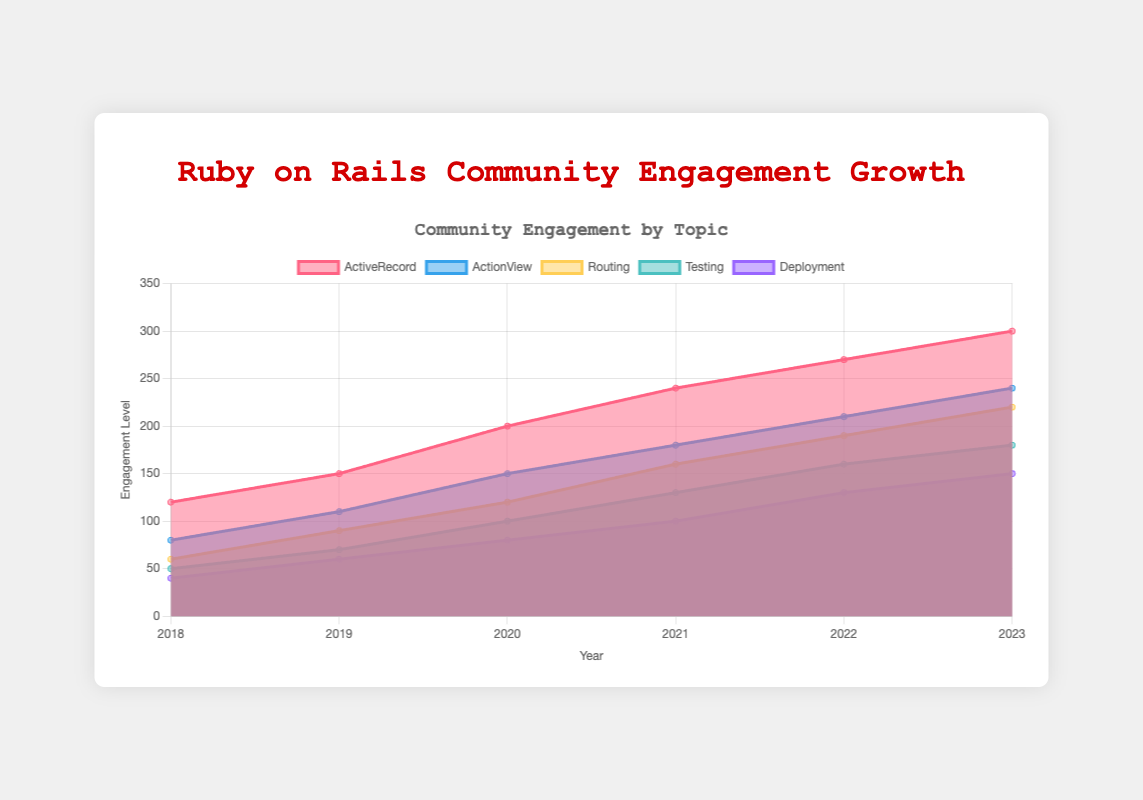What is the title of the chart? The title of the chart is displayed prominently at the top of the figure.
Answer: Ruby on Rails Community Engagement Growth How many topics are represented in the area chart? By observing the legend and the different colored areas, we can count five distinct topics.
Answer: Five What trend is displayed by the 'ActiveRecord' engagement from 2018 to 2023? The 'ActiveRecord' engagement shows a steady increase over the years from 120 in 2018 to 300 in 2023.
Answer: Steady increase Which topic had the highest engagement in 2023? By looking at the labels and their corresponding values in 2023, 'ActiveRecord' had the highest engagement with a value of 300.
Answer: ActiveRecord Compare the 'Deployment' engagement in 2020 and 2023. How much did it increase by? The 'Deployment' engagement in 2020 was 80, and in 2023 it was 150. The increase is calculated as 150 - 80.
Answer: 70 What was the engagement level for 'ActionView' in 2021? By locating the 'ActionView' dataset and matching it to the year 2021, we find the engagement level was 180.
Answer: 180 Did any topic show a decrease in engagement over the years? Observing all the datasets over the years, none of the topics showed a decrease; they all trended upwards.
Answer: No Which topic had the second highest engagement level in 2022? By comparing the engagement levels of each topic in 2022, 'ActionView' had the second highest engagement with a value of 210.
Answer: ActionView Calculate the total community engagement across all topics in 2019. Add the engagement values of all topics for 2019: 150 (ActiveRecord) + 110 (ActionView) + 90 (Routing) + 70 (Testing) + 60 (Deployment) = 480.
Answer: 480 What is the average increase in engagement for 'Testing' from 2018 to 2023? First, calculate the total increase over the years: 180 (2023) - 50 (2018) = 130. Then, divide by the number of years: 130 / (2023 - 2018) = 130 / 5.
Answer: 26 